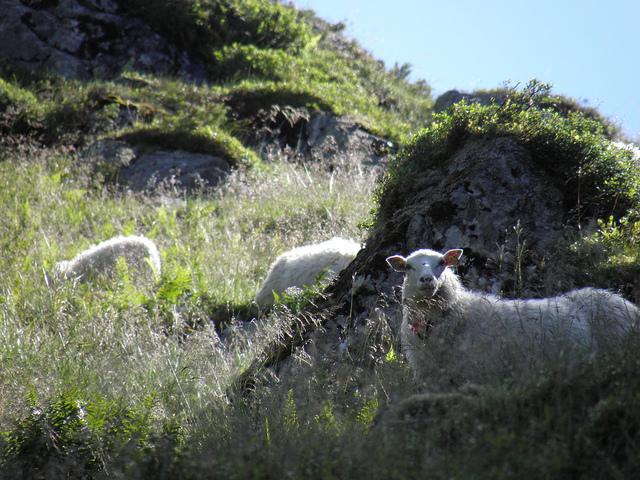Which lamb is on the rock?
Keep it brief. None. Are the animals in a zoo?
Concise answer only. No. Is this on a mountainside?
Give a very brief answer. Yes. What date was this picture taken?
Be succinct. 7/21/14. What color is the face of the sheep?
Concise answer only. White. Are these sheep full grown?
Concise answer only. Yes. Is modern technology depicted?
Short answer required. No. 